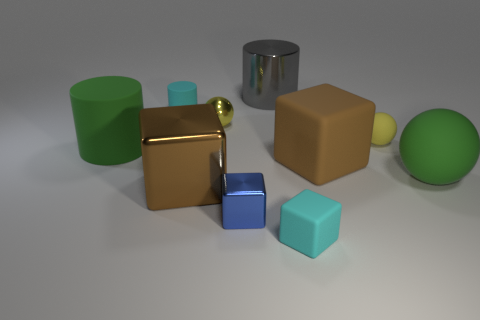Is the shape of the large gray object the same as the small yellow rubber object?
Offer a very short reply. No. What number of large things are both behind the small cyan matte cylinder and on the right side of the tiny rubber block?
Provide a short and direct response. 0. How many objects are either brown objects or tiny matte things on the right side of the big gray cylinder?
Your answer should be compact. 4. Are there more purple objects than blue metal blocks?
Your answer should be compact. No. There is a big brown object to the right of the tiny cyan cube; what is its shape?
Ensure brevity in your answer.  Cube. What number of large brown rubber objects have the same shape as the blue metallic object?
Your answer should be compact. 1. How big is the green object that is left of the cyan matte object that is right of the cyan cylinder?
Provide a succinct answer. Large. How many green things are either matte blocks or tiny rubber objects?
Provide a short and direct response. 0. Are there fewer large green objects on the right side of the gray shiny thing than yellow matte things that are behind the small cyan rubber cylinder?
Make the answer very short. No. Do the blue metal block and the metallic object that is on the left side of the small yellow shiny sphere have the same size?
Ensure brevity in your answer.  No. 